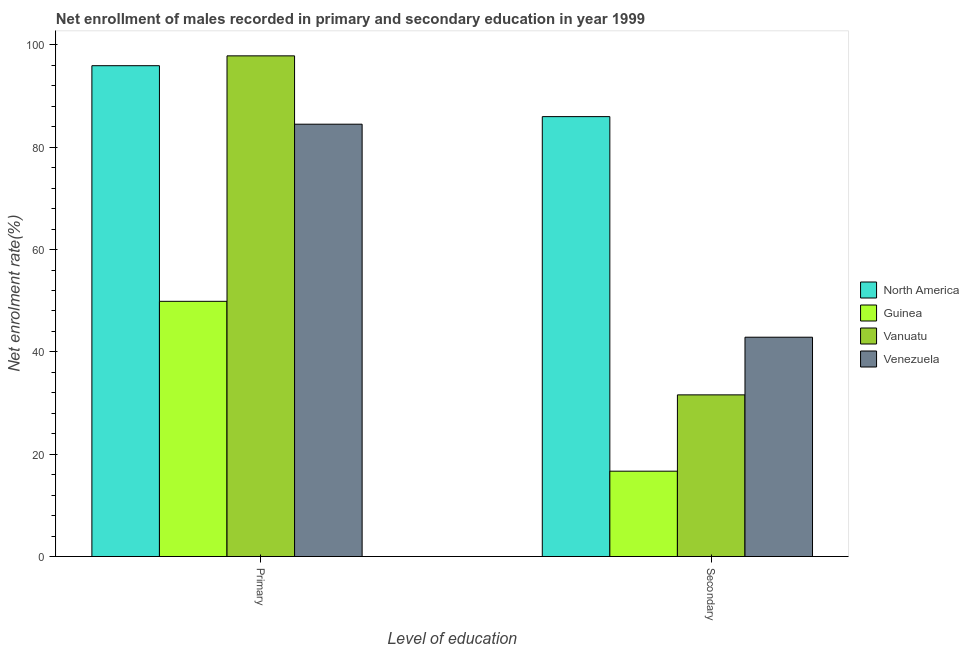How many different coloured bars are there?
Provide a succinct answer. 4. How many groups of bars are there?
Provide a short and direct response. 2. Are the number of bars on each tick of the X-axis equal?
Provide a short and direct response. Yes. How many bars are there on the 2nd tick from the left?
Provide a succinct answer. 4. What is the label of the 2nd group of bars from the left?
Offer a very short reply. Secondary. What is the enrollment rate in secondary education in Venezuela?
Your answer should be compact. 42.87. Across all countries, what is the maximum enrollment rate in secondary education?
Your answer should be very brief. 85.99. Across all countries, what is the minimum enrollment rate in primary education?
Keep it short and to the point. 49.88. In which country was the enrollment rate in secondary education maximum?
Make the answer very short. North America. In which country was the enrollment rate in secondary education minimum?
Provide a succinct answer. Guinea. What is the total enrollment rate in primary education in the graph?
Keep it short and to the point. 328.2. What is the difference between the enrollment rate in primary education in Guinea and that in Vanuatu?
Make the answer very short. -47.98. What is the difference between the enrollment rate in secondary education in Venezuela and the enrollment rate in primary education in Guinea?
Your answer should be very brief. -7.02. What is the average enrollment rate in primary education per country?
Your answer should be very brief. 82.05. What is the difference between the enrollment rate in secondary education and enrollment rate in primary education in Vanuatu?
Your answer should be compact. -66.27. What is the ratio of the enrollment rate in primary education in North America to that in Venezuela?
Offer a very short reply. 1.14. Is the enrollment rate in secondary education in Guinea less than that in Venezuela?
Provide a short and direct response. Yes. In how many countries, is the enrollment rate in primary education greater than the average enrollment rate in primary education taken over all countries?
Keep it short and to the point. 3. What does the 3rd bar from the left in Primary represents?
Offer a very short reply. Vanuatu. What does the 3rd bar from the right in Primary represents?
Provide a succinct answer. Guinea. How many bars are there?
Offer a very short reply. 8. How many countries are there in the graph?
Keep it short and to the point. 4. Are the values on the major ticks of Y-axis written in scientific E-notation?
Your response must be concise. No. Does the graph contain grids?
Give a very brief answer. No. How many legend labels are there?
Offer a terse response. 4. What is the title of the graph?
Offer a terse response. Net enrollment of males recorded in primary and secondary education in year 1999. Does "New Zealand" appear as one of the legend labels in the graph?
Ensure brevity in your answer.  No. What is the label or title of the X-axis?
Provide a succinct answer. Level of education. What is the label or title of the Y-axis?
Offer a very short reply. Net enrolment rate(%). What is the Net enrolment rate(%) of North America in Primary?
Offer a terse response. 95.94. What is the Net enrolment rate(%) of Guinea in Primary?
Your answer should be compact. 49.88. What is the Net enrolment rate(%) of Vanuatu in Primary?
Provide a short and direct response. 97.86. What is the Net enrolment rate(%) in Venezuela in Primary?
Your answer should be very brief. 84.51. What is the Net enrolment rate(%) in North America in Secondary?
Ensure brevity in your answer.  85.99. What is the Net enrolment rate(%) of Guinea in Secondary?
Give a very brief answer. 16.68. What is the Net enrolment rate(%) in Vanuatu in Secondary?
Provide a succinct answer. 31.6. What is the Net enrolment rate(%) of Venezuela in Secondary?
Offer a terse response. 42.87. Across all Level of education, what is the maximum Net enrolment rate(%) in North America?
Your answer should be compact. 95.94. Across all Level of education, what is the maximum Net enrolment rate(%) of Guinea?
Your answer should be very brief. 49.88. Across all Level of education, what is the maximum Net enrolment rate(%) of Vanuatu?
Your answer should be compact. 97.86. Across all Level of education, what is the maximum Net enrolment rate(%) in Venezuela?
Provide a succinct answer. 84.51. Across all Level of education, what is the minimum Net enrolment rate(%) of North America?
Ensure brevity in your answer.  85.99. Across all Level of education, what is the minimum Net enrolment rate(%) in Guinea?
Make the answer very short. 16.68. Across all Level of education, what is the minimum Net enrolment rate(%) of Vanuatu?
Provide a succinct answer. 31.6. Across all Level of education, what is the minimum Net enrolment rate(%) of Venezuela?
Give a very brief answer. 42.87. What is the total Net enrolment rate(%) of North America in the graph?
Your response must be concise. 181.93. What is the total Net enrolment rate(%) of Guinea in the graph?
Keep it short and to the point. 66.57. What is the total Net enrolment rate(%) of Vanuatu in the graph?
Ensure brevity in your answer.  129.46. What is the total Net enrolment rate(%) in Venezuela in the graph?
Give a very brief answer. 127.38. What is the difference between the Net enrolment rate(%) in North America in Primary and that in Secondary?
Provide a short and direct response. 9.96. What is the difference between the Net enrolment rate(%) of Guinea in Primary and that in Secondary?
Ensure brevity in your answer.  33.2. What is the difference between the Net enrolment rate(%) in Vanuatu in Primary and that in Secondary?
Offer a very short reply. 66.27. What is the difference between the Net enrolment rate(%) in Venezuela in Primary and that in Secondary?
Your response must be concise. 41.64. What is the difference between the Net enrolment rate(%) in North America in Primary and the Net enrolment rate(%) in Guinea in Secondary?
Offer a terse response. 79.26. What is the difference between the Net enrolment rate(%) of North America in Primary and the Net enrolment rate(%) of Vanuatu in Secondary?
Give a very brief answer. 64.34. What is the difference between the Net enrolment rate(%) of North America in Primary and the Net enrolment rate(%) of Venezuela in Secondary?
Provide a short and direct response. 53.07. What is the difference between the Net enrolment rate(%) of Guinea in Primary and the Net enrolment rate(%) of Vanuatu in Secondary?
Your answer should be compact. 18.29. What is the difference between the Net enrolment rate(%) in Guinea in Primary and the Net enrolment rate(%) in Venezuela in Secondary?
Your response must be concise. 7.02. What is the difference between the Net enrolment rate(%) of Vanuatu in Primary and the Net enrolment rate(%) of Venezuela in Secondary?
Make the answer very short. 54.99. What is the average Net enrolment rate(%) in North America per Level of education?
Provide a short and direct response. 90.96. What is the average Net enrolment rate(%) in Guinea per Level of education?
Your answer should be compact. 33.28. What is the average Net enrolment rate(%) in Vanuatu per Level of education?
Ensure brevity in your answer.  64.73. What is the average Net enrolment rate(%) of Venezuela per Level of education?
Provide a short and direct response. 63.69. What is the difference between the Net enrolment rate(%) in North America and Net enrolment rate(%) in Guinea in Primary?
Give a very brief answer. 46.06. What is the difference between the Net enrolment rate(%) in North America and Net enrolment rate(%) in Vanuatu in Primary?
Keep it short and to the point. -1.92. What is the difference between the Net enrolment rate(%) in North America and Net enrolment rate(%) in Venezuela in Primary?
Offer a terse response. 11.44. What is the difference between the Net enrolment rate(%) of Guinea and Net enrolment rate(%) of Vanuatu in Primary?
Your response must be concise. -47.98. What is the difference between the Net enrolment rate(%) of Guinea and Net enrolment rate(%) of Venezuela in Primary?
Make the answer very short. -34.62. What is the difference between the Net enrolment rate(%) of Vanuatu and Net enrolment rate(%) of Venezuela in Primary?
Your answer should be compact. 13.36. What is the difference between the Net enrolment rate(%) of North America and Net enrolment rate(%) of Guinea in Secondary?
Your response must be concise. 69.31. What is the difference between the Net enrolment rate(%) of North America and Net enrolment rate(%) of Vanuatu in Secondary?
Provide a succinct answer. 54.39. What is the difference between the Net enrolment rate(%) in North America and Net enrolment rate(%) in Venezuela in Secondary?
Your response must be concise. 43.12. What is the difference between the Net enrolment rate(%) in Guinea and Net enrolment rate(%) in Vanuatu in Secondary?
Give a very brief answer. -14.92. What is the difference between the Net enrolment rate(%) of Guinea and Net enrolment rate(%) of Venezuela in Secondary?
Your answer should be compact. -26.19. What is the difference between the Net enrolment rate(%) in Vanuatu and Net enrolment rate(%) in Venezuela in Secondary?
Ensure brevity in your answer.  -11.27. What is the ratio of the Net enrolment rate(%) of North America in Primary to that in Secondary?
Your response must be concise. 1.12. What is the ratio of the Net enrolment rate(%) of Guinea in Primary to that in Secondary?
Offer a very short reply. 2.99. What is the ratio of the Net enrolment rate(%) of Vanuatu in Primary to that in Secondary?
Your answer should be very brief. 3.1. What is the ratio of the Net enrolment rate(%) in Venezuela in Primary to that in Secondary?
Offer a very short reply. 1.97. What is the difference between the highest and the second highest Net enrolment rate(%) of North America?
Provide a short and direct response. 9.96. What is the difference between the highest and the second highest Net enrolment rate(%) of Guinea?
Provide a succinct answer. 33.2. What is the difference between the highest and the second highest Net enrolment rate(%) in Vanuatu?
Ensure brevity in your answer.  66.27. What is the difference between the highest and the second highest Net enrolment rate(%) of Venezuela?
Provide a short and direct response. 41.64. What is the difference between the highest and the lowest Net enrolment rate(%) of North America?
Your answer should be compact. 9.96. What is the difference between the highest and the lowest Net enrolment rate(%) in Guinea?
Offer a terse response. 33.2. What is the difference between the highest and the lowest Net enrolment rate(%) in Vanuatu?
Offer a terse response. 66.27. What is the difference between the highest and the lowest Net enrolment rate(%) of Venezuela?
Your answer should be very brief. 41.64. 